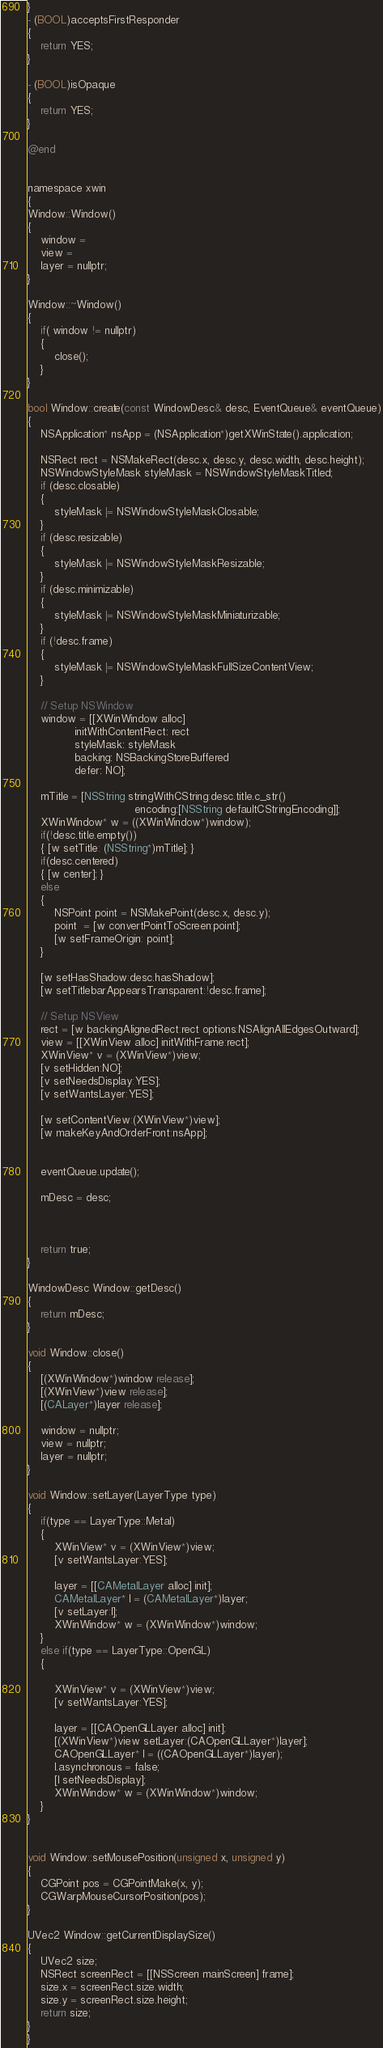<code> <loc_0><loc_0><loc_500><loc_500><_ObjectiveC_>}
- (BOOL)acceptsFirstResponder
{
	return YES;
}

- (BOOL)isOpaque
{
	return YES;
}

@end


namespace xwin
{	
Window::Window()
{
	window =
	view =
	layer = nullptr;
}

Window::~Window()
{
	if( window != nullptr)
	{
		close();
	}
}

bool Window::create(const WindowDesc& desc, EventQueue& eventQueue)
{
	NSApplication* nsApp = (NSApplication*)getXWinState().application;
	
	NSRect rect = NSMakeRect(desc.x, desc.y, desc.width, desc.height);
	NSWindowStyleMask styleMask = NSWindowStyleMaskTitled;
	if (desc.closable)
	{
		styleMask |= NSWindowStyleMaskClosable;
	}
	if (desc.resizable)
	{
		styleMask |= NSWindowStyleMaskResizable;
	}
	if (desc.minimizable)
	{
		styleMask |= NSWindowStyleMaskMiniaturizable;
	}
	if (!desc.frame)
	{
		styleMask |= NSWindowStyleMaskFullSizeContentView;
	}
	
	// Setup NSWindow
	window = [[XWinWindow alloc]
			  initWithContentRect: rect
			  styleMask: styleMask
			  backing: NSBackingStoreBuffered
			  defer: NO];
	
	mTitle = [NSString stringWithCString:desc.title.c_str()
								encoding:[NSString defaultCStringEncoding]];
	XWinWindow* w = ((XWinWindow*)window);
	if(!desc.title.empty())
	{ [w setTitle: (NSString*)mTitle]; }
	if(desc.centered)
	{ [w center]; }
	else
	{
		NSPoint point = NSMakePoint(desc.x, desc.y);
		point  = [w convertPointToScreen:point];
		[w setFrameOrigin: point];
	}
	
	[w setHasShadow:desc.hasShadow];
	[w setTitlebarAppearsTransparent:!desc.frame];

	// Setup NSView
	rect = [w backingAlignedRect:rect options:NSAlignAllEdgesOutward];
	view = [[XWinView alloc] initWithFrame:rect];
	XWinView* v = (XWinView*)view;
	[v setHidden:NO];
	[v setNeedsDisplay:YES];
	[v setWantsLayer:YES];

	[w setContentView:(XWinView*)view];
	[w makeKeyAndOrderFront:nsApp];
	
	
	eventQueue.update();
	
	mDesc = desc;
	
	
	
	return true;
}

WindowDesc Window::getDesc()
{
	return mDesc;
}

void Window::close()
{
	[(XWinWindow*)window release];
	[(XWinView*)view release];
	[(CALayer*)layer release];
	
	window = nullptr;
	view = nullptr;
	layer = nullptr;
}

void Window::setLayer(LayerType type)
{
	if(type == LayerType::Metal)
	{
		XWinView* v = (XWinView*)view;
		[v setWantsLayer:YES];
		
		layer = [[CAMetalLayer alloc] init];
		CAMetalLayer* l = (CAMetalLayer*)layer;
		[v setLayer:l];
		XWinWindow* w = (XWinWindow*)window;
	}
	else if(type == LayerType::OpenGL)
	{
		
		XWinView* v = (XWinView*)view;
		[v setWantsLayer:YES];
		
		layer = [[CAOpenGLLayer alloc] init];
		[(XWinView*)view setLayer:(CAOpenGLLayer*)layer];
		CAOpenGLLayer* l = ((CAOpenGLLayer*)layer);
		l.asynchronous = false;
		[l setNeedsDisplay];
		XWinWindow* w = (XWinWindow*)window;
	}
}


void Window::setMousePosition(unsigned x, unsigned y)
{
	CGPoint pos = CGPointMake(x, y);
	CGWarpMouseCursorPosition(pos);
}

UVec2 Window::getCurrentDisplaySize()
{
	UVec2 size;
	NSRect screenRect = [[NSScreen mainScreen] frame];
	size.x = screenRect.size.width;
	size.y = screenRect.size.height;
	return size;
}
}
</code> 